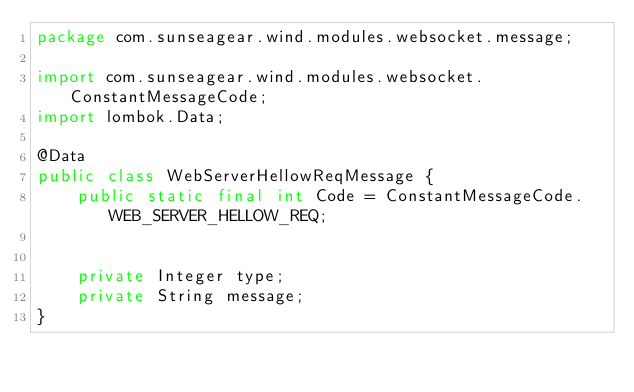Convert code to text. <code><loc_0><loc_0><loc_500><loc_500><_Java_>package com.sunseagear.wind.modules.websocket.message;

import com.sunseagear.wind.modules.websocket.ConstantMessageCode;
import lombok.Data;

@Data
public class WebServerHellowReqMessage {
    public static final int Code = ConstantMessageCode.WEB_SERVER_HELLOW_REQ;


    private Integer type;
    private String message;
}
</code> 